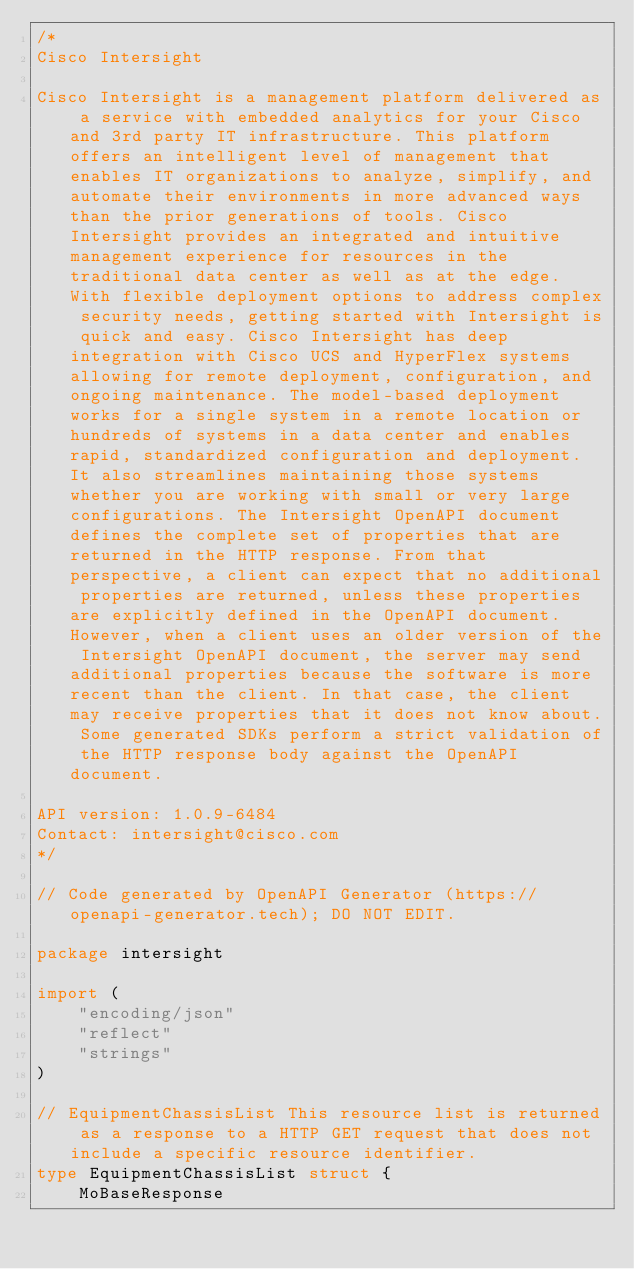<code> <loc_0><loc_0><loc_500><loc_500><_Go_>/*
Cisco Intersight

Cisco Intersight is a management platform delivered as a service with embedded analytics for your Cisco and 3rd party IT infrastructure. This platform offers an intelligent level of management that enables IT organizations to analyze, simplify, and automate their environments in more advanced ways than the prior generations of tools. Cisco Intersight provides an integrated and intuitive management experience for resources in the traditional data center as well as at the edge. With flexible deployment options to address complex security needs, getting started with Intersight is quick and easy. Cisco Intersight has deep integration with Cisco UCS and HyperFlex systems allowing for remote deployment, configuration, and ongoing maintenance. The model-based deployment works for a single system in a remote location or hundreds of systems in a data center and enables rapid, standardized configuration and deployment. It also streamlines maintaining those systems whether you are working with small or very large configurations. The Intersight OpenAPI document defines the complete set of properties that are returned in the HTTP response. From that perspective, a client can expect that no additional properties are returned, unless these properties are explicitly defined in the OpenAPI document. However, when a client uses an older version of the Intersight OpenAPI document, the server may send additional properties because the software is more recent than the client. In that case, the client may receive properties that it does not know about. Some generated SDKs perform a strict validation of the HTTP response body against the OpenAPI document.

API version: 1.0.9-6484
Contact: intersight@cisco.com
*/

// Code generated by OpenAPI Generator (https://openapi-generator.tech); DO NOT EDIT.

package intersight

import (
	"encoding/json"
	"reflect"
	"strings"
)

// EquipmentChassisList This resource list is returned as a response to a HTTP GET request that does not include a specific resource identifier.
type EquipmentChassisList struct {
	MoBaseResponse</code> 